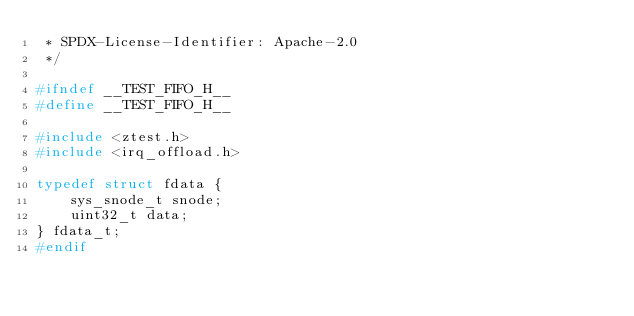<code> <loc_0><loc_0><loc_500><loc_500><_C_> * SPDX-License-Identifier: Apache-2.0
 */

#ifndef __TEST_FIFO_H__
#define __TEST_FIFO_H__

#include <ztest.h>
#include <irq_offload.h>

typedef struct fdata {
	sys_snode_t snode;
	uint32_t data;
} fdata_t;
#endif
</code> 